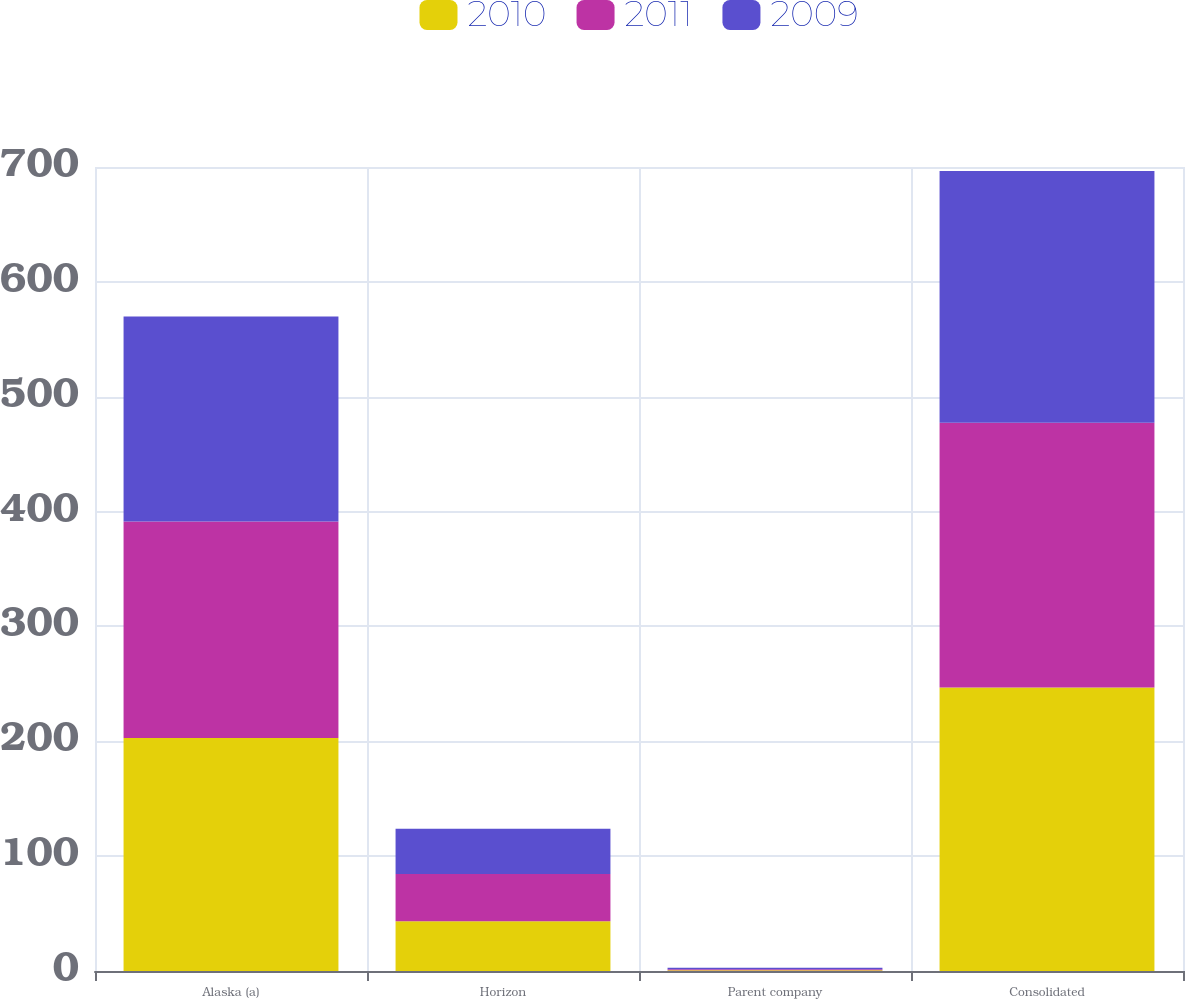<chart> <loc_0><loc_0><loc_500><loc_500><stacked_bar_chart><ecel><fcel>Alaska (a)<fcel>Horizon<fcel>Parent company<fcel>Consolidated<nl><fcel>2010<fcel>202.9<fcel>43.4<fcel>0.6<fcel>246.9<nl><fcel>2011<fcel>188.5<fcel>41<fcel>1<fcel>230.5<nl><fcel>2009<fcel>178.5<fcel>39.5<fcel>1.2<fcel>219.2<nl></chart> 